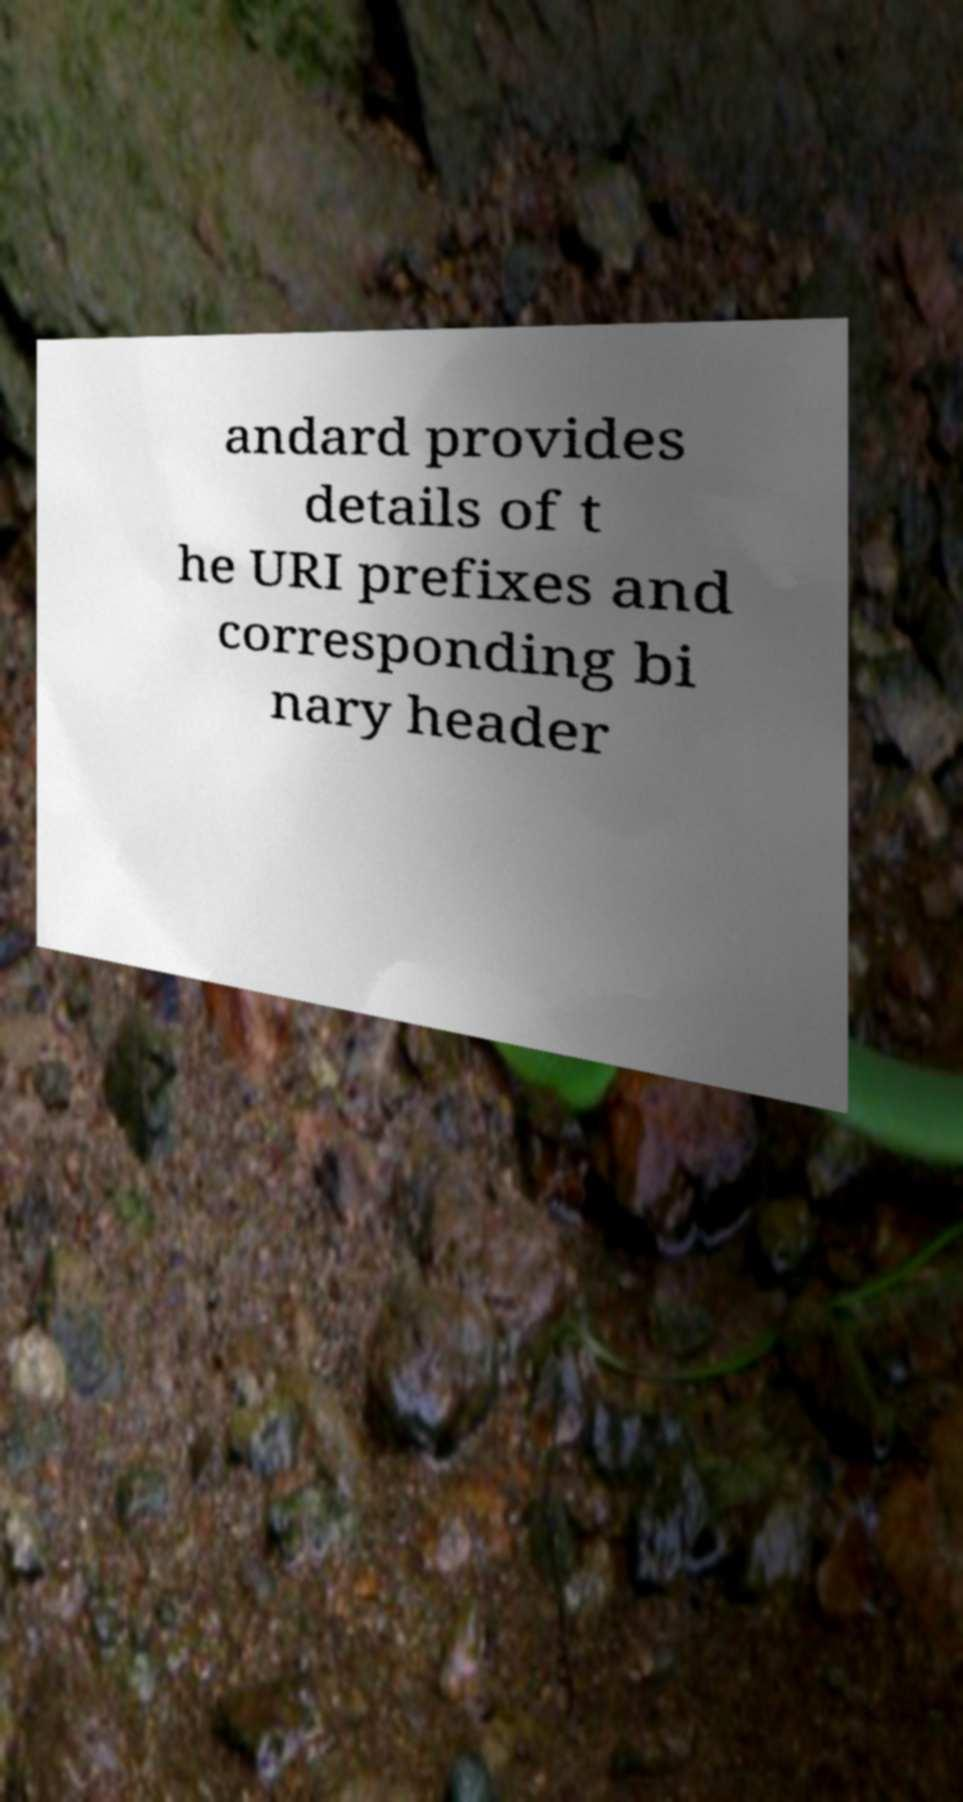Please read and relay the text visible in this image. What does it say? andard provides details of t he URI prefixes and corresponding bi nary header 